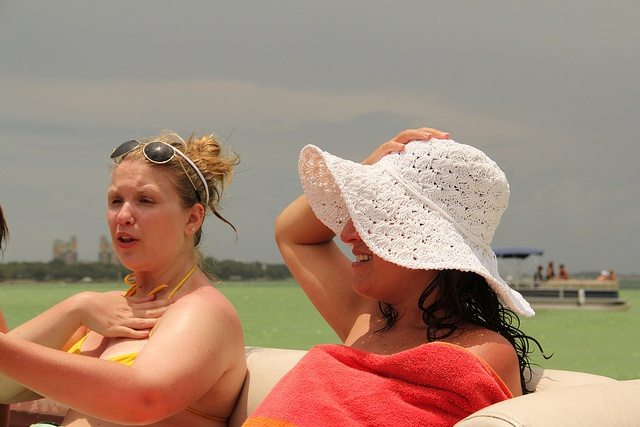Describe the objects in this image and their specific colors. I can see people in gray, brown, salmon, and tan tones, people in gray, brown, maroon, and black tones, couch in gray, tan, and beige tones, boat in gray and black tones, and people in gray, black, and maroon tones in this image. 